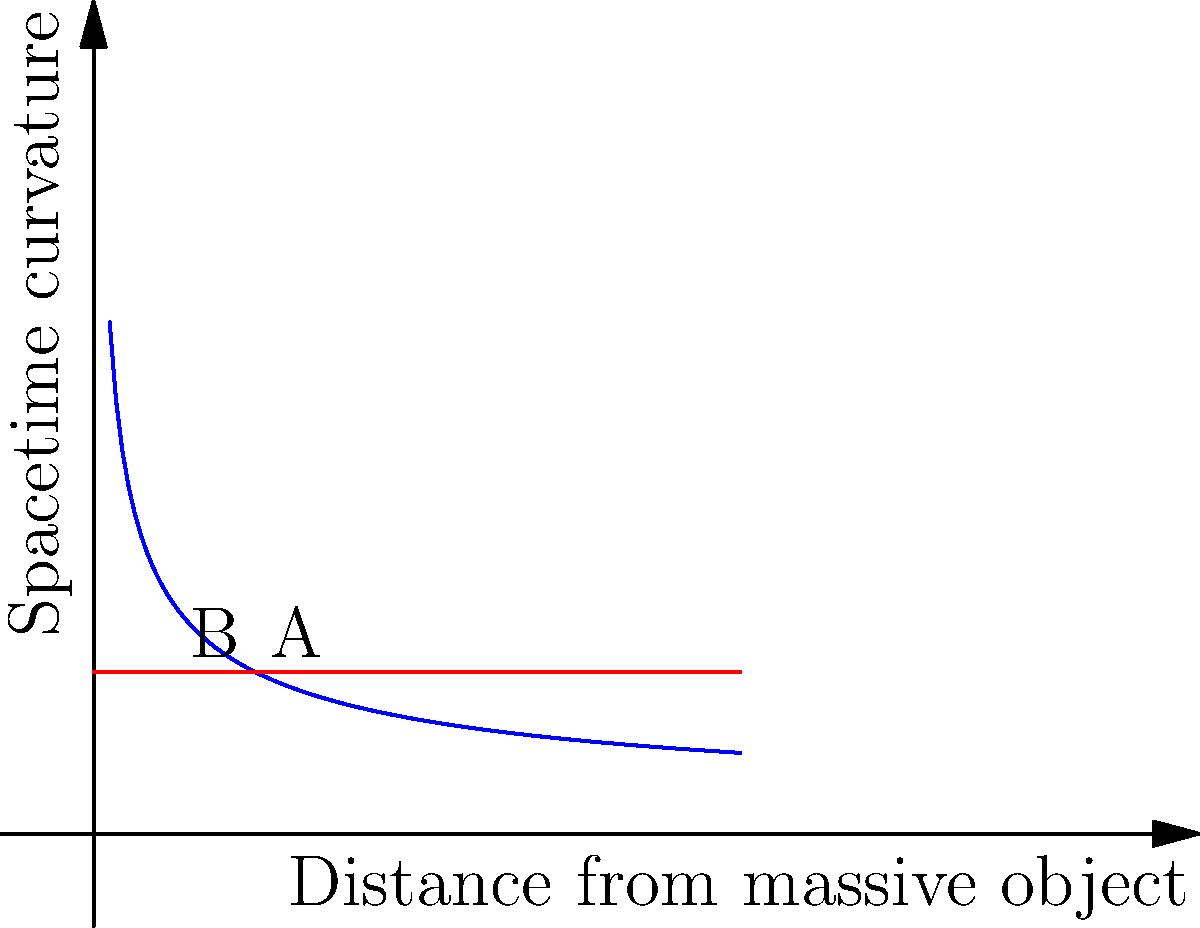Consider the graph representing the curvature of spacetime near a massive object. The blue curve shows the actual curvature, while the red line represents flat spacetime. At point A, the spacetime curvature is $\frac{1}{\sqrt{x}}$, where $x$ is the distance from the massive object. What is the ratio of the curvature at point A to the curvature at point B? To solve this problem, we need to follow these steps:

1) The curvature at point A is given by the function $f(x) = \frac{1}{\sqrt{x}}$.
   At $x = 1$, the curvature is $f(1) = \frac{1}{\sqrt{1}} = 1$.

2) The curvature at point B is represented by the flat spacetime line, which has a constant value of 1 for all $x$.

3) The ratio of curvature at A to B is:

   $$\frac{\text{Curvature at A}}{\text{Curvature at B}} = \frac{f(1)}{1} = \frac{1}{1} = 1$$

This result indicates that at $x = 1$, the curved spacetime has the same curvature as flat spacetime. As we move closer to the massive object ($x < 1$), the curvature increases, and as we move farther ($x > 1$), the curvature decreases, asymptotically approaching flat spacetime.
Answer: 1 